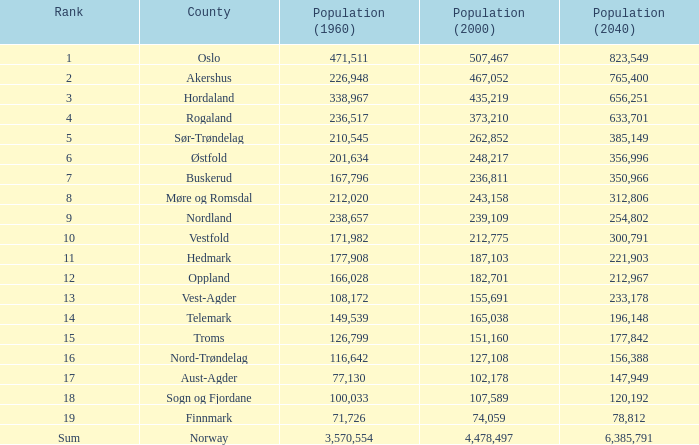In 2040, what was the population of a county that recorded less than 108,172 people in 2000 and less than 107,589 in 1960? 2.0. 